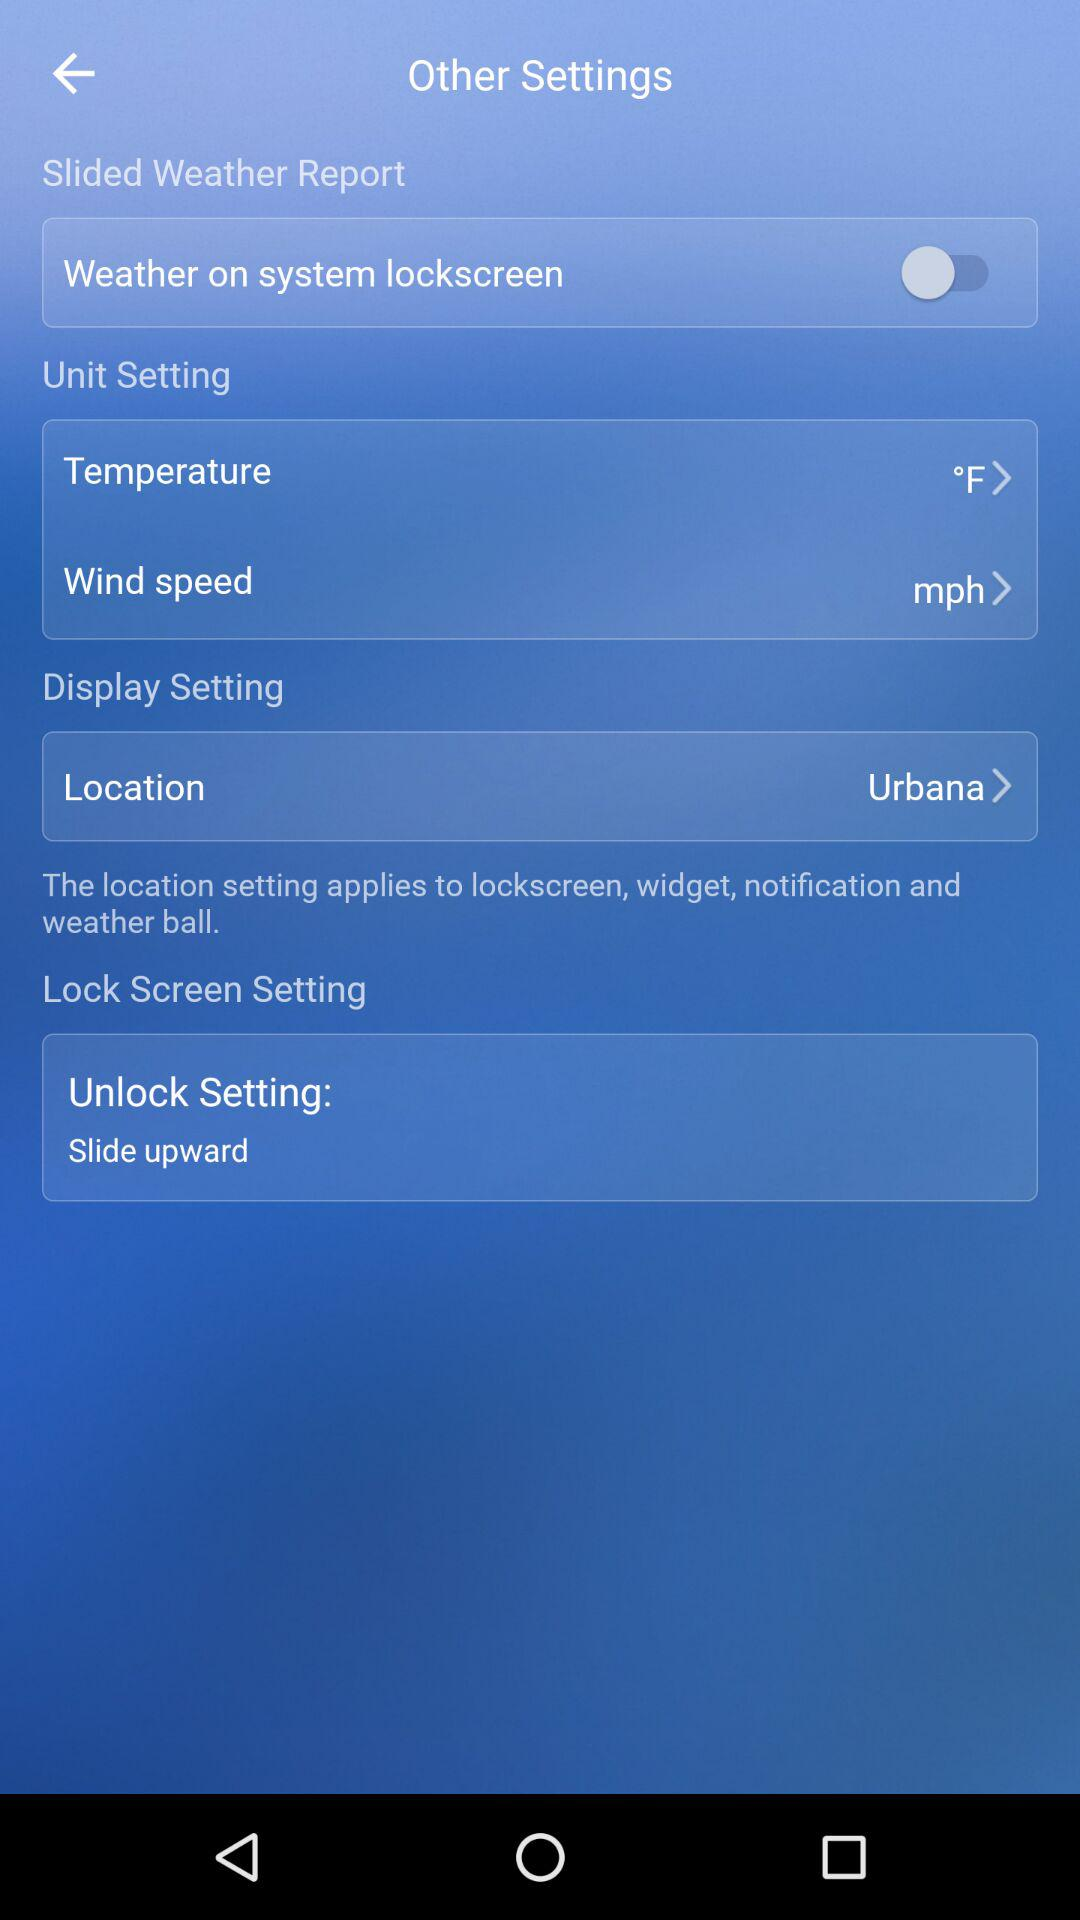What's the status of "Weather on system lockscreen"? The status of "Weather on system lockscreen" is "off". 